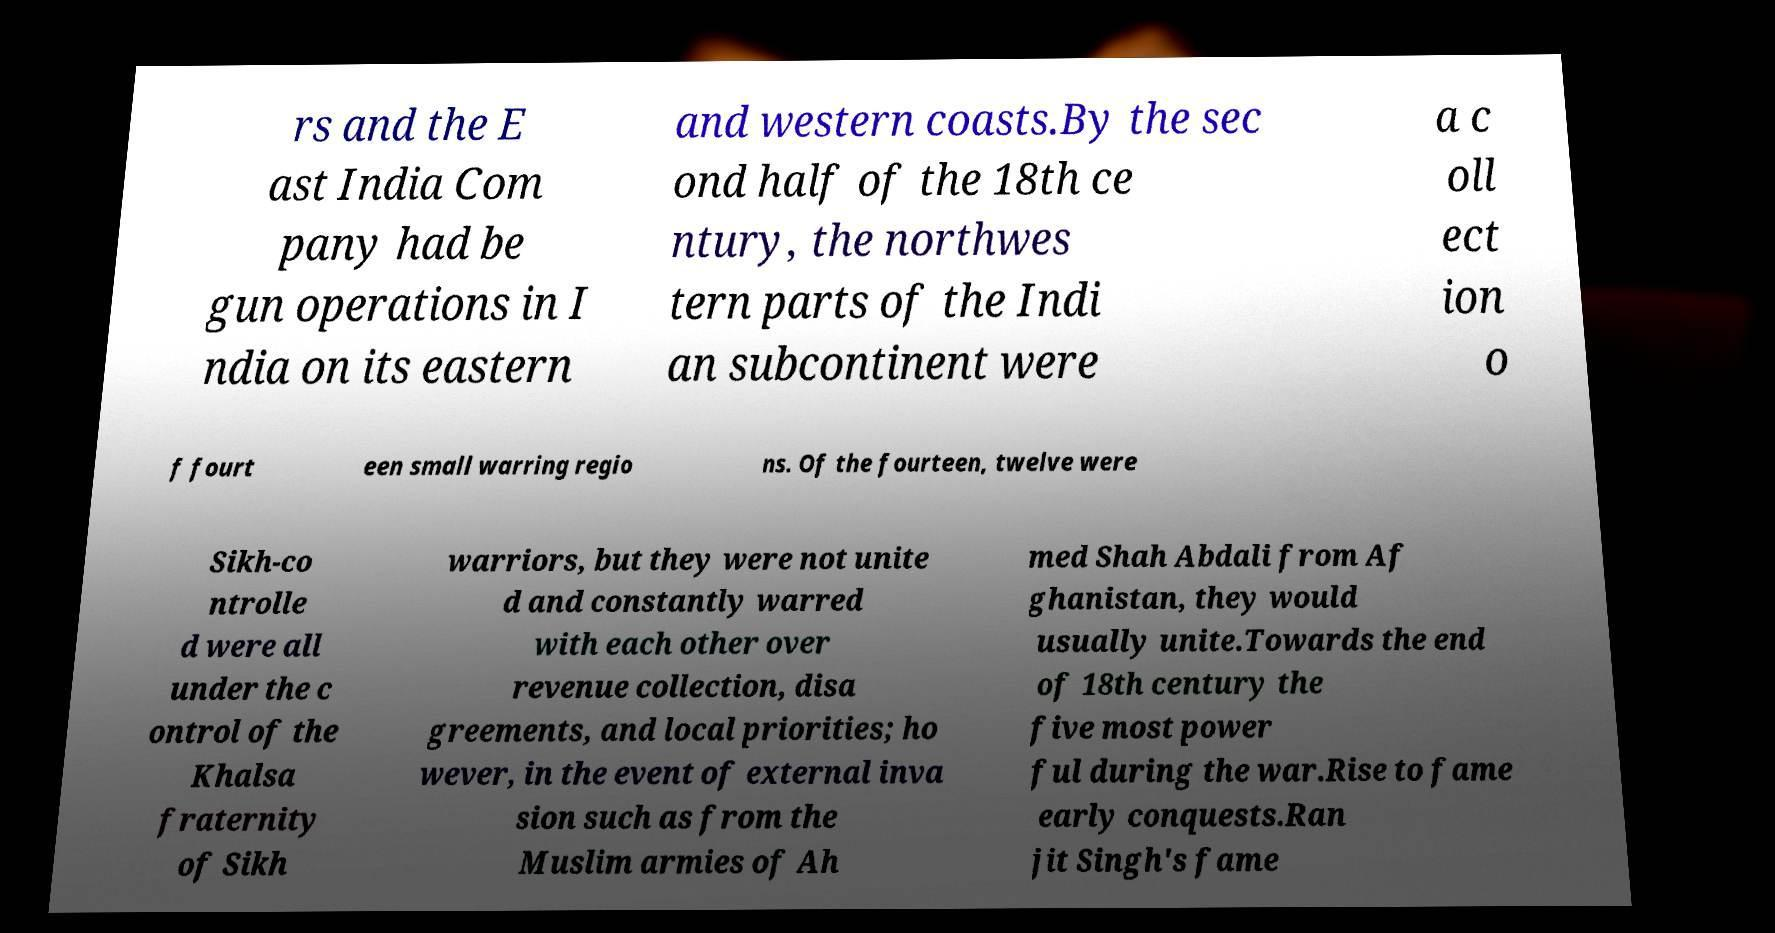For documentation purposes, I need the text within this image transcribed. Could you provide that? rs and the E ast India Com pany had be gun operations in I ndia on its eastern and western coasts.By the sec ond half of the 18th ce ntury, the northwes tern parts of the Indi an subcontinent were a c oll ect ion o f fourt een small warring regio ns. Of the fourteen, twelve were Sikh-co ntrolle d were all under the c ontrol of the Khalsa fraternity of Sikh warriors, but they were not unite d and constantly warred with each other over revenue collection, disa greements, and local priorities; ho wever, in the event of external inva sion such as from the Muslim armies of Ah med Shah Abdali from Af ghanistan, they would usually unite.Towards the end of 18th century the five most power ful during the war.Rise to fame early conquests.Ran jit Singh's fame 